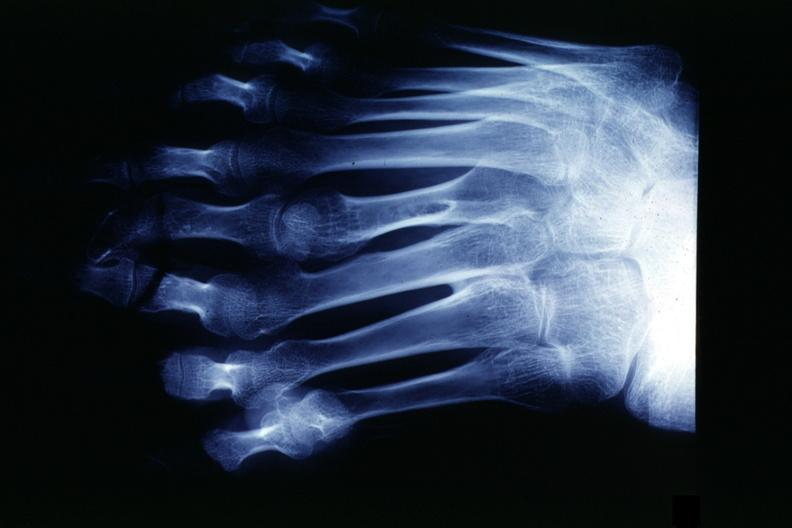does this image show x-ray strange foot with 8 digits?
Answer the question using a single word or phrase. Yes 